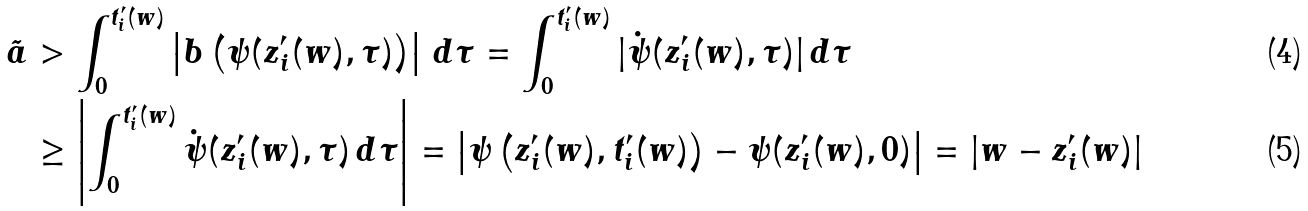<formula> <loc_0><loc_0><loc_500><loc_500>\tilde { a } & > \int _ { 0 } ^ { t _ { i } ^ { \prime } ( w ) } \left | b \left ( \psi ( z _ { i } ^ { \prime } ( w ) , \tau ) \right ) \right | \, d \tau = \int _ { 0 } ^ { t _ { i } ^ { \prime } ( w ) } | \dot { \psi } ( z _ { i } ^ { \prime } ( w ) , \tau ) | \, d \tau \\ & \geq \left | \int _ { 0 } ^ { t _ { i } ^ { \prime } ( w ) } \dot { \psi } ( z _ { i } ^ { \prime } ( w ) , \tau ) \, d \tau \right | = \left | \psi \left ( z _ { i } ^ { \prime } ( w ) , t _ { i } ^ { \prime } ( w ) \right ) - \psi ( z _ { i } ^ { \prime } ( w ) , 0 ) \right | = | w - z _ { i } ^ { \prime } ( w ) |</formula> 